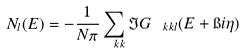Convert formula to latex. <formula><loc_0><loc_0><loc_500><loc_500>N _ { l } ( E ) = - \frac { 1 } { N \pi } \sum _ { \ k k } \Im G _ { \ k k l } ( E + \i i \eta )</formula> 